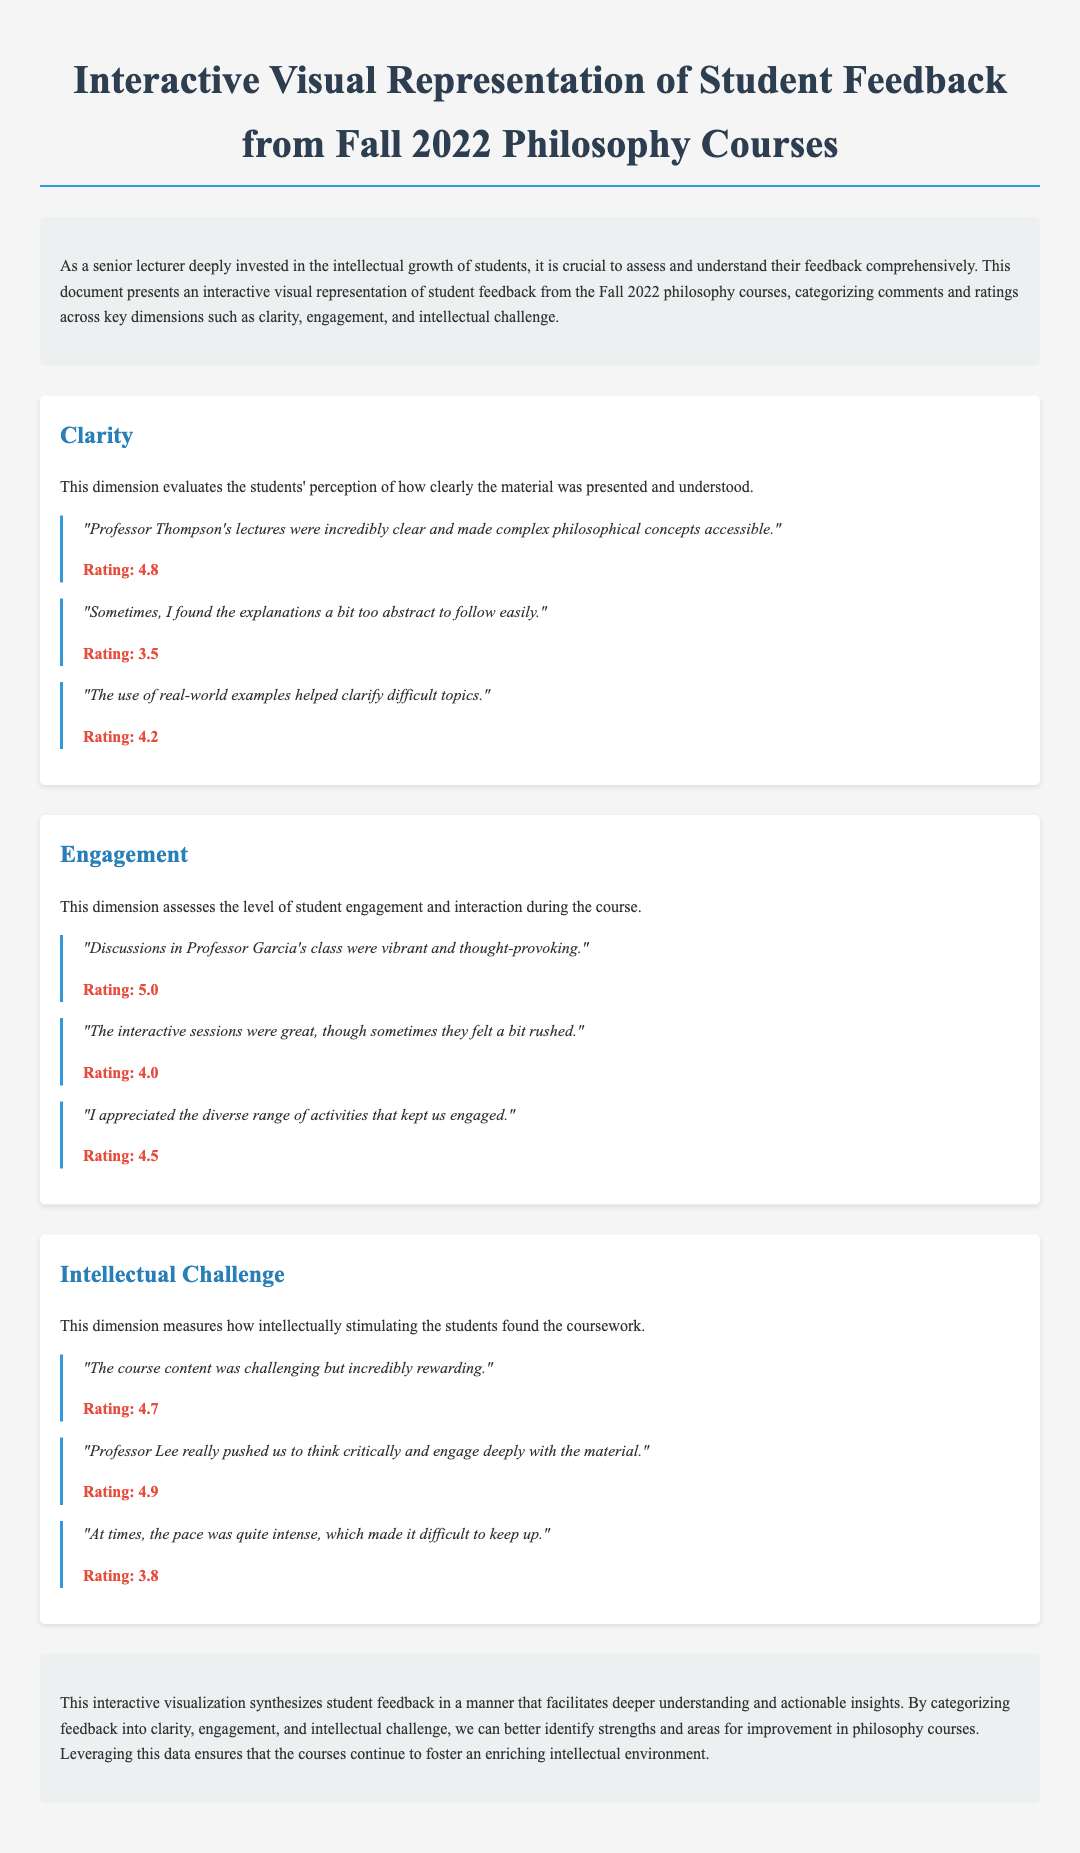What is the title of the document? The title is displayed prominently at the top of the document, clearly indicating the subject matter.
Answer: Interactive Visual Representation of Student Feedback from Fall 2022 Philosophy Courses How many dimensions of feedback are evaluated? The document mentions three specific dimensions that are used to categorize the feedback received from students.
Answer: Three What was the highest rating for engagement? The document provides feedback ratings for engagement, with one comment receiving the maximum score in this dimension.
Answer: 5.0 Which professor's lectures were described as incredibly clear? The feedback specifically mentions the effectiveness of one professor's lectures in terms of clarity in presenting complex concepts.
Answer: Professor Thompson What was the rating for the comment that indicates the course content was challenging? The document lists various comments and their respective ratings, including one that reflects on the challenging nature of the coursework.
Answer: 4.7 What feedback element helped clarify difficult topics? The students highlighted a specific aspect of the teaching approach that contributed positively to their understanding of the material.
Answer: Real-world examples Which dimension received a comment about it being sometimes too abstract? The document categorizes feedback, and one specific dimension discusses clarity with a comment regarding its abstract nature.
Answer: Clarity What is the concluding sentiment expressed about leveraging student feedback? The conclusion summarizes the intent of reviewing and utilizing feedback for the educational environment in the philosophy courses.
Answer: Enriching intellectual environment What was the rating from the comment about feeling the interactive sessions were rushed? One of the comments in the engagement section notes a perception regarding the pacing of the interactive parts of the course.
Answer: 4.0 